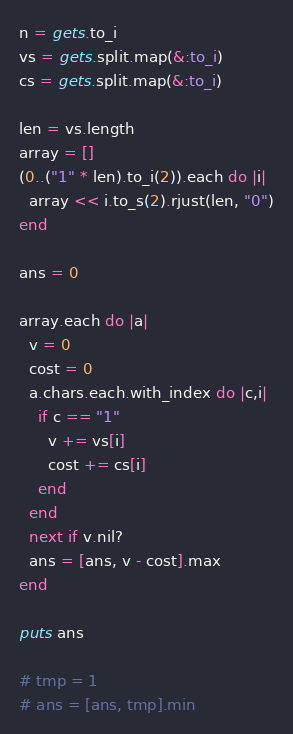Convert code to text. <code><loc_0><loc_0><loc_500><loc_500><_Ruby_>n = gets.to_i
vs = gets.split.map(&:to_i)
cs = gets.split.map(&:to_i)

len = vs.length
array = []
(0..("1" * len).to_i(2)).each do |i|
  array << i.to_s(2).rjust(len, "0")
end

ans = 0

array.each do |a|
  v = 0
  cost = 0
  a.chars.each.with_index do |c,i|
    if c == "1"
      v += vs[i]
      cost += cs[i]
    end
  end
  next if v.nil?
  ans = [ans, v - cost].max
end

puts ans

# tmp = 1
# ans = [ans, tmp].min
</code> 